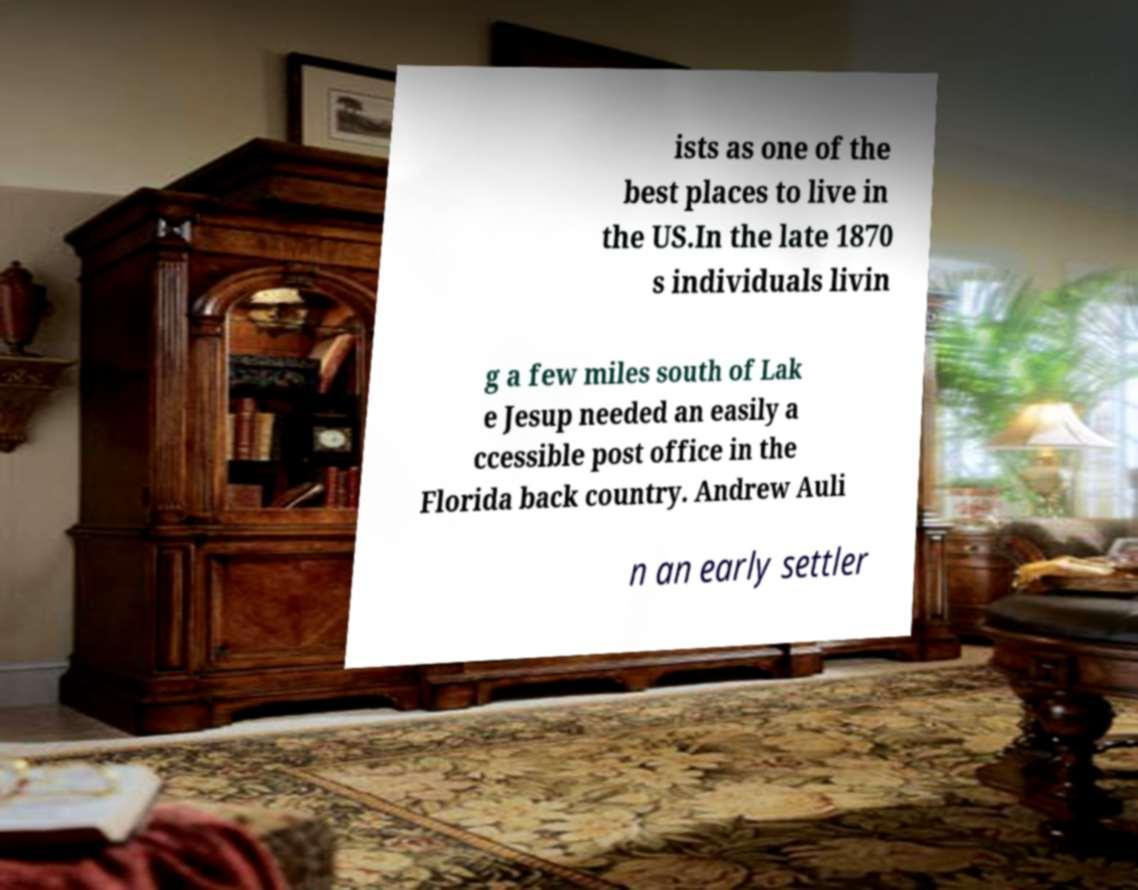Could you assist in decoding the text presented in this image and type it out clearly? ists as one of the best places to live in the US.In the late 1870 s individuals livin g a few miles south of Lak e Jesup needed an easily a ccessible post office in the Florida back country. Andrew Auli n an early settler 